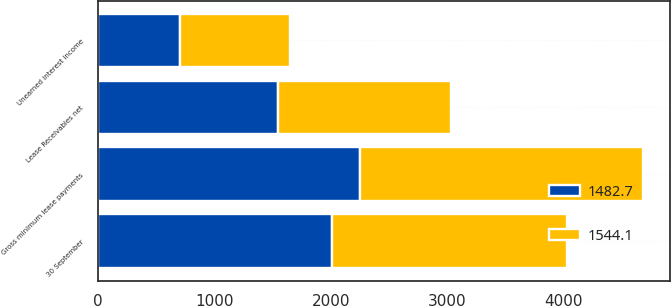<chart> <loc_0><loc_0><loc_500><loc_500><stacked_bar_chart><ecel><fcel>30 September<fcel>Gross minimum lease payments<fcel>Unearned interest income<fcel>Lease Receivables net<nl><fcel>1544.1<fcel>2014<fcel>2423.3<fcel>940.6<fcel>1482.7<nl><fcel>1482.7<fcel>2013<fcel>2253.2<fcel>709.1<fcel>1544.1<nl></chart> 